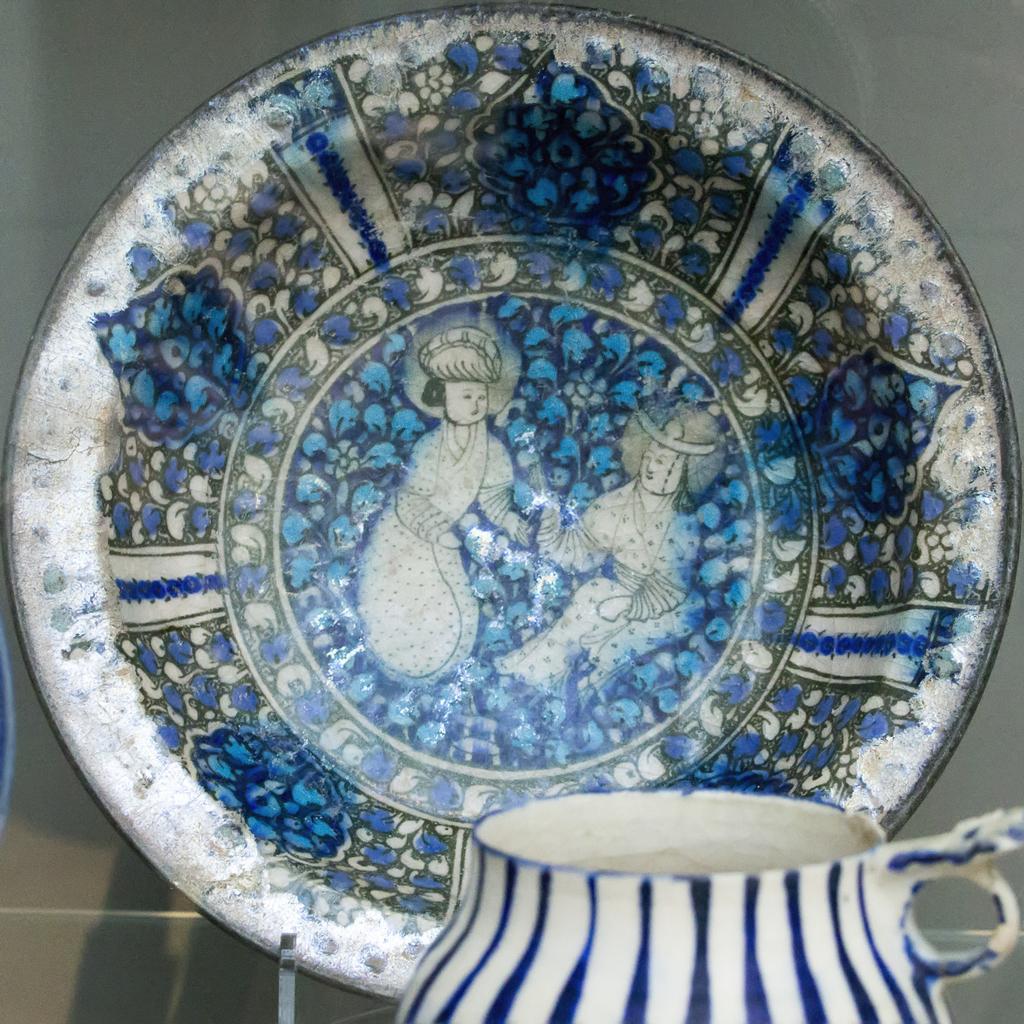Could you give a brief overview of what you see in this image? In this image I can see a plate which is white and blue in color and I can see a cup which is white and blue in color in front of the plate. 